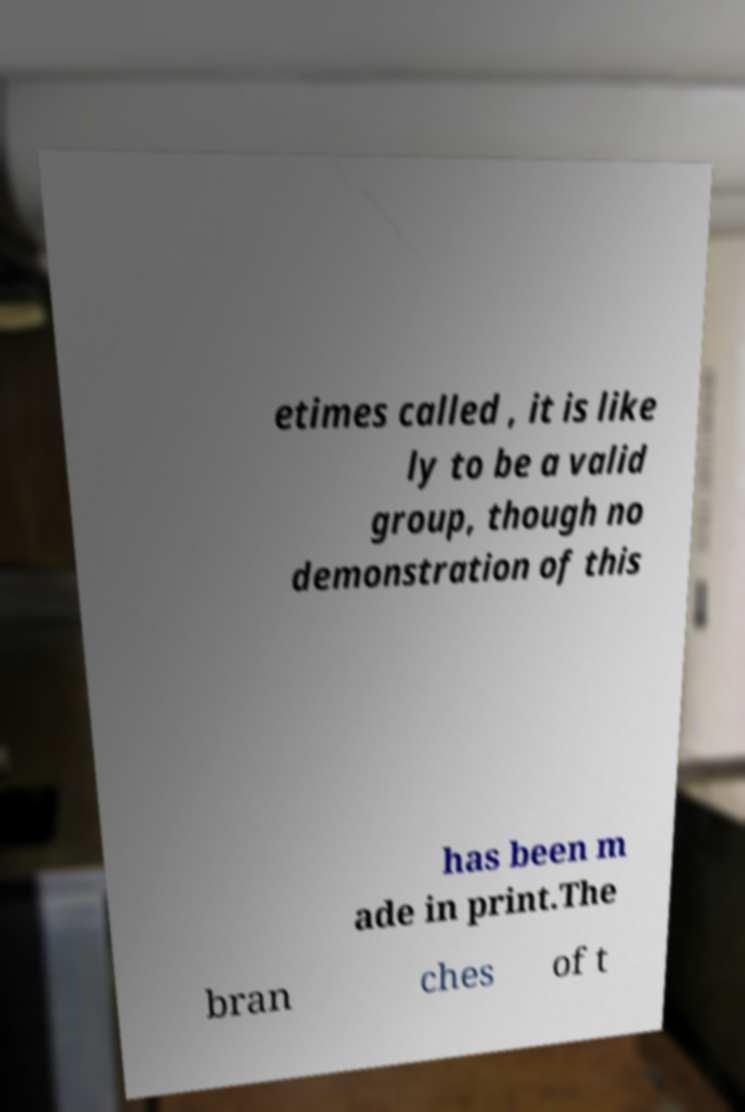Can you accurately transcribe the text from the provided image for me? etimes called , it is like ly to be a valid group, though no demonstration of this has been m ade in print.The bran ches of t 